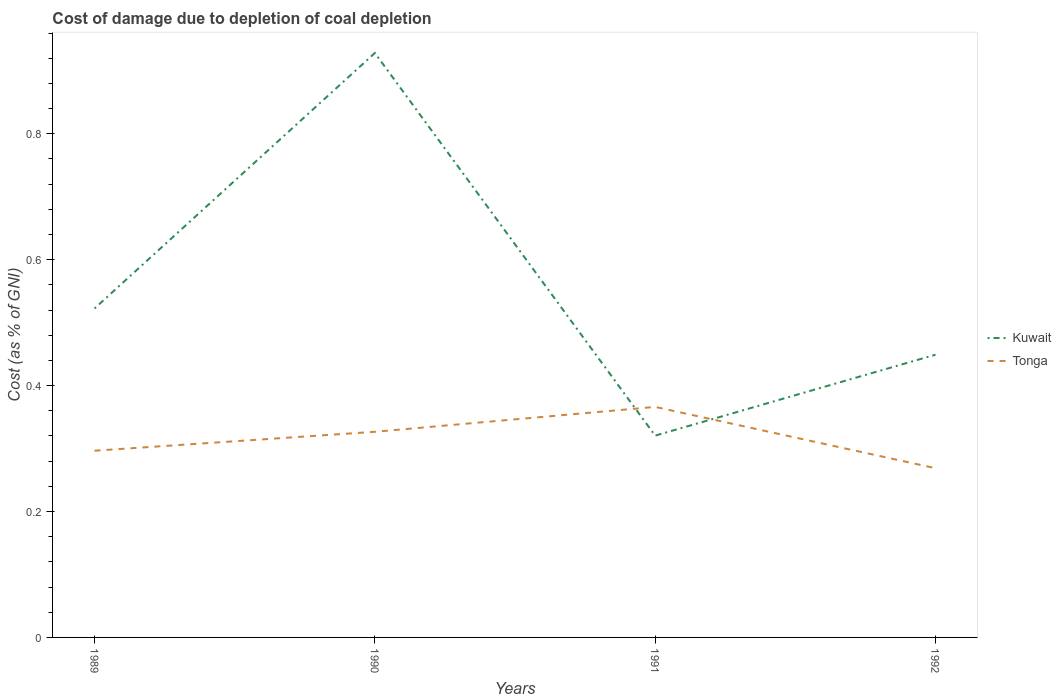How many different coloured lines are there?
Your answer should be very brief. 2. Across all years, what is the maximum cost of damage caused due to coal depletion in Kuwait?
Give a very brief answer. 0.32. What is the total cost of damage caused due to coal depletion in Tonga in the graph?
Your answer should be compact. 0.1. What is the difference between the highest and the second highest cost of damage caused due to coal depletion in Kuwait?
Offer a terse response. 0.61. What is the difference between the highest and the lowest cost of damage caused due to coal depletion in Tonga?
Give a very brief answer. 2. Are the values on the major ticks of Y-axis written in scientific E-notation?
Give a very brief answer. No. Does the graph contain grids?
Make the answer very short. No. Where does the legend appear in the graph?
Ensure brevity in your answer.  Center right. What is the title of the graph?
Ensure brevity in your answer.  Cost of damage due to depletion of coal depletion. What is the label or title of the X-axis?
Your answer should be very brief. Years. What is the label or title of the Y-axis?
Make the answer very short. Cost (as % of GNI). What is the Cost (as % of GNI) in Kuwait in 1989?
Keep it short and to the point. 0.52. What is the Cost (as % of GNI) of Tonga in 1989?
Ensure brevity in your answer.  0.3. What is the Cost (as % of GNI) of Kuwait in 1990?
Give a very brief answer. 0.93. What is the Cost (as % of GNI) in Tonga in 1990?
Your response must be concise. 0.33. What is the Cost (as % of GNI) of Kuwait in 1991?
Offer a very short reply. 0.32. What is the Cost (as % of GNI) of Tonga in 1991?
Your response must be concise. 0.37. What is the Cost (as % of GNI) of Kuwait in 1992?
Offer a terse response. 0.45. What is the Cost (as % of GNI) of Tonga in 1992?
Give a very brief answer. 0.27. Across all years, what is the maximum Cost (as % of GNI) of Kuwait?
Make the answer very short. 0.93. Across all years, what is the maximum Cost (as % of GNI) in Tonga?
Offer a terse response. 0.37. Across all years, what is the minimum Cost (as % of GNI) of Kuwait?
Your answer should be compact. 0.32. Across all years, what is the minimum Cost (as % of GNI) in Tonga?
Keep it short and to the point. 0.27. What is the total Cost (as % of GNI) in Kuwait in the graph?
Make the answer very short. 2.22. What is the total Cost (as % of GNI) in Tonga in the graph?
Ensure brevity in your answer.  1.26. What is the difference between the Cost (as % of GNI) of Kuwait in 1989 and that in 1990?
Keep it short and to the point. -0.41. What is the difference between the Cost (as % of GNI) of Tonga in 1989 and that in 1990?
Ensure brevity in your answer.  -0.03. What is the difference between the Cost (as % of GNI) of Kuwait in 1989 and that in 1991?
Make the answer very short. 0.2. What is the difference between the Cost (as % of GNI) in Tonga in 1989 and that in 1991?
Offer a terse response. -0.07. What is the difference between the Cost (as % of GNI) of Kuwait in 1989 and that in 1992?
Make the answer very short. 0.07. What is the difference between the Cost (as % of GNI) in Tonga in 1989 and that in 1992?
Provide a succinct answer. 0.03. What is the difference between the Cost (as % of GNI) of Kuwait in 1990 and that in 1991?
Ensure brevity in your answer.  0.61. What is the difference between the Cost (as % of GNI) of Tonga in 1990 and that in 1991?
Your answer should be compact. -0.04. What is the difference between the Cost (as % of GNI) of Kuwait in 1990 and that in 1992?
Make the answer very short. 0.48. What is the difference between the Cost (as % of GNI) in Tonga in 1990 and that in 1992?
Give a very brief answer. 0.06. What is the difference between the Cost (as % of GNI) of Kuwait in 1991 and that in 1992?
Provide a succinct answer. -0.13. What is the difference between the Cost (as % of GNI) of Tonga in 1991 and that in 1992?
Provide a succinct answer. 0.1. What is the difference between the Cost (as % of GNI) in Kuwait in 1989 and the Cost (as % of GNI) in Tonga in 1990?
Provide a succinct answer. 0.2. What is the difference between the Cost (as % of GNI) in Kuwait in 1989 and the Cost (as % of GNI) in Tonga in 1991?
Offer a terse response. 0.16. What is the difference between the Cost (as % of GNI) in Kuwait in 1989 and the Cost (as % of GNI) in Tonga in 1992?
Make the answer very short. 0.25. What is the difference between the Cost (as % of GNI) of Kuwait in 1990 and the Cost (as % of GNI) of Tonga in 1991?
Keep it short and to the point. 0.56. What is the difference between the Cost (as % of GNI) in Kuwait in 1990 and the Cost (as % of GNI) in Tonga in 1992?
Give a very brief answer. 0.66. What is the difference between the Cost (as % of GNI) in Kuwait in 1991 and the Cost (as % of GNI) in Tonga in 1992?
Provide a succinct answer. 0.05. What is the average Cost (as % of GNI) of Kuwait per year?
Provide a succinct answer. 0.56. What is the average Cost (as % of GNI) in Tonga per year?
Ensure brevity in your answer.  0.31. In the year 1989, what is the difference between the Cost (as % of GNI) in Kuwait and Cost (as % of GNI) in Tonga?
Ensure brevity in your answer.  0.23. In the year 1990, what is the difference between the Cost (as % of GNI) in Kuwait and Cost (as % of GNI) in Tonga?
Provide a succinct answer. 0.6. In the year 1991, what is the difference between the Cost (as % of GNI) in Kuwait and Cost (as % of GNI) in Tonga?
Ensure brevity in your answer.  -0.05. In the year 1992, what is the difference between the Cost (as % of GNI) in Kuwait and Cost (as % of GNI) in Tonga?
Your answer should be compact. 0.18. What is the ratio of the Cost (as % of GNI) in Kuwait in 1989 to that in 1990?
Keep it short and to the point. 0.56. What is the ratio of the Cost (as % of GNI) of Tonga in 1989 to that in 1990?
Ensure brevity in your answer.  0.91. What is the ratio of the Cost (as % of GNI) in Kuwait in 1989 to that in 1991?
Your response must be concise. 1.63. What is the ratio of the Cost (as % of GNI) in Tonga in 1989 to that in 1991?
Your response must be concise. 0.81. What is the ratio of the Cost (as % of GNI) of Kuwait in 1989 to that in 1992?
Make the answer very short. 1.16. What is the ratio of the Cost (as % of GNI) of Tonga in 1989 to that in 1992?
Ensure brevity in your answer.  1.1. What is the ratio of the Cost (as % of GNI) in Kuwait in 1990 to that in 1991?
Your answer should be compact. 2.9. What is the ratio of the Cost (as % of GNI) in Tonga in 1990 to that in 1991?
Give a very brief answer. 0.89. What is the ratio of the Cost (as % of GNI) of Kuwait in 1990 to that in 1992?
Your response must be concise. 2.07. What is the ratio of the Cost (as % of GNI) in Tonga in 1990 to that in 1992?
Provide a short and direct response. 1.22. What is the ratio of the Cost (as % of GNI) of Kuwait in 1991 to that in 1992?
Your answer should be very brief. 0.71. What is the ratio of the Cost (as % of GNI) in Tonga in 1991 to that in 1992?
Your answer should be compact. 1.36. What is the difference between the highest and the second highest Cost (as % of GNI) in Kuwait?
Ensure brevity in your answer.  0.41. What is the difference between the highest and the second highest Cost (as % of GNI) in Tonga?
Provide a succinct answer. 0.04. What is the difference between the highest and the lowest Cost (as % of GNI) in Kuwait?
Your answer should be compact. 0.61. What is the difference between the highest and the lowest Cost (as % of GNI) of Tonga?
Give a very brief answer. 0.1. 